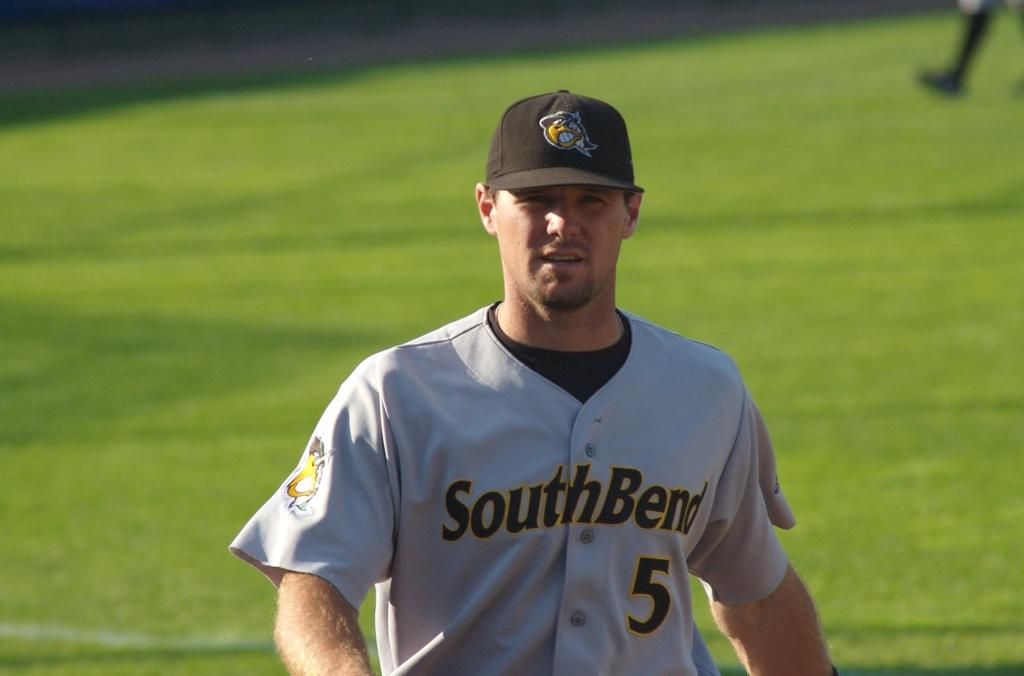<image>
Render a clear and concise summary of the photo. A baseball player in a South Bend shirt with 5 on it. 